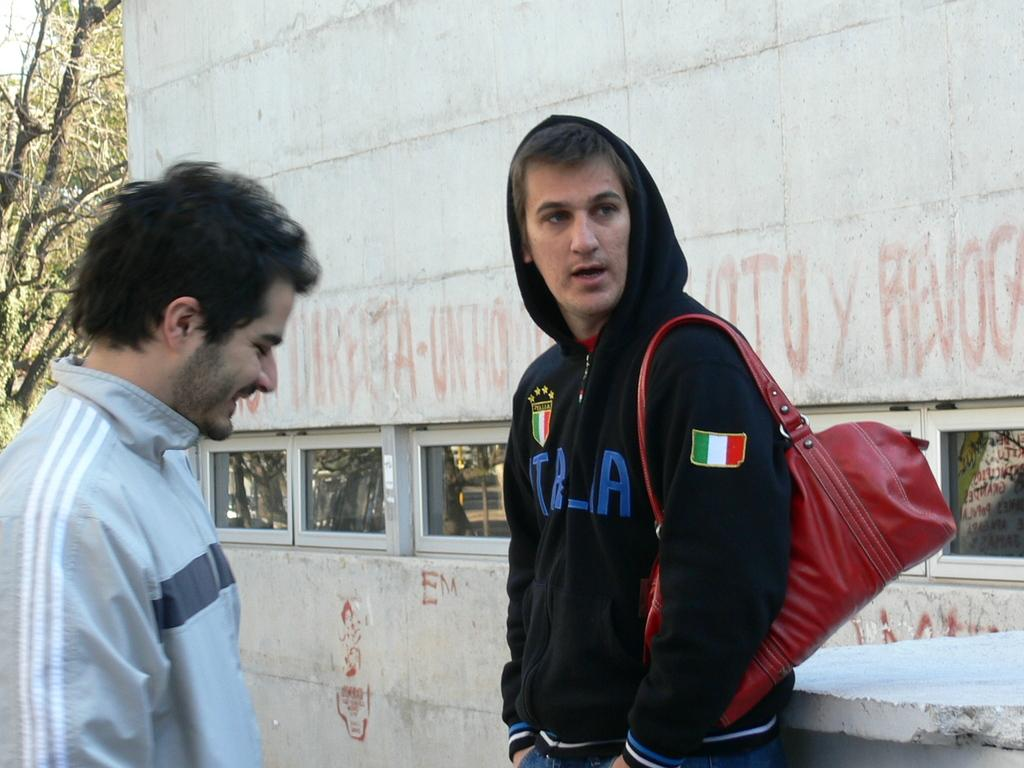<image>
Describe the image concisely. Two men talking near a white wall, one of the wearing a black Italia hoodie. 